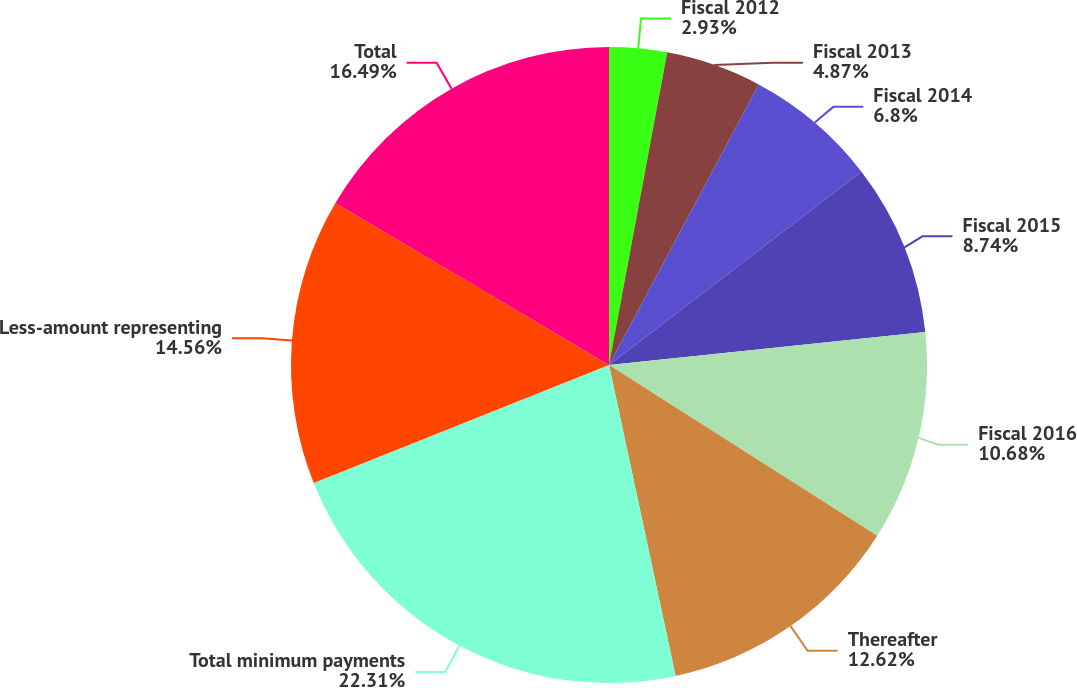Convert chart to OTSL. <chart><loc_0><loc_0><loc_500><loc_500><pie_chart><fcel>Fiscal 2012<fcel>Fiscal 2013<fcel>Fiscal 2014<fcel>Fiscal 2015<fcel>Fiscal 2016<fcel>Thereafter<fcel>Total minimum payments<fcel>Less-amount representing<fcel>Total<nl><fcel>2.93%<fcel>4.87%<fcel>6.8%<fcel>8.74%<fcel>10.68%<fcel>12.62%<fcel>22.31%<fcel>14.56%<fcel>16.49%<nl></chart> 